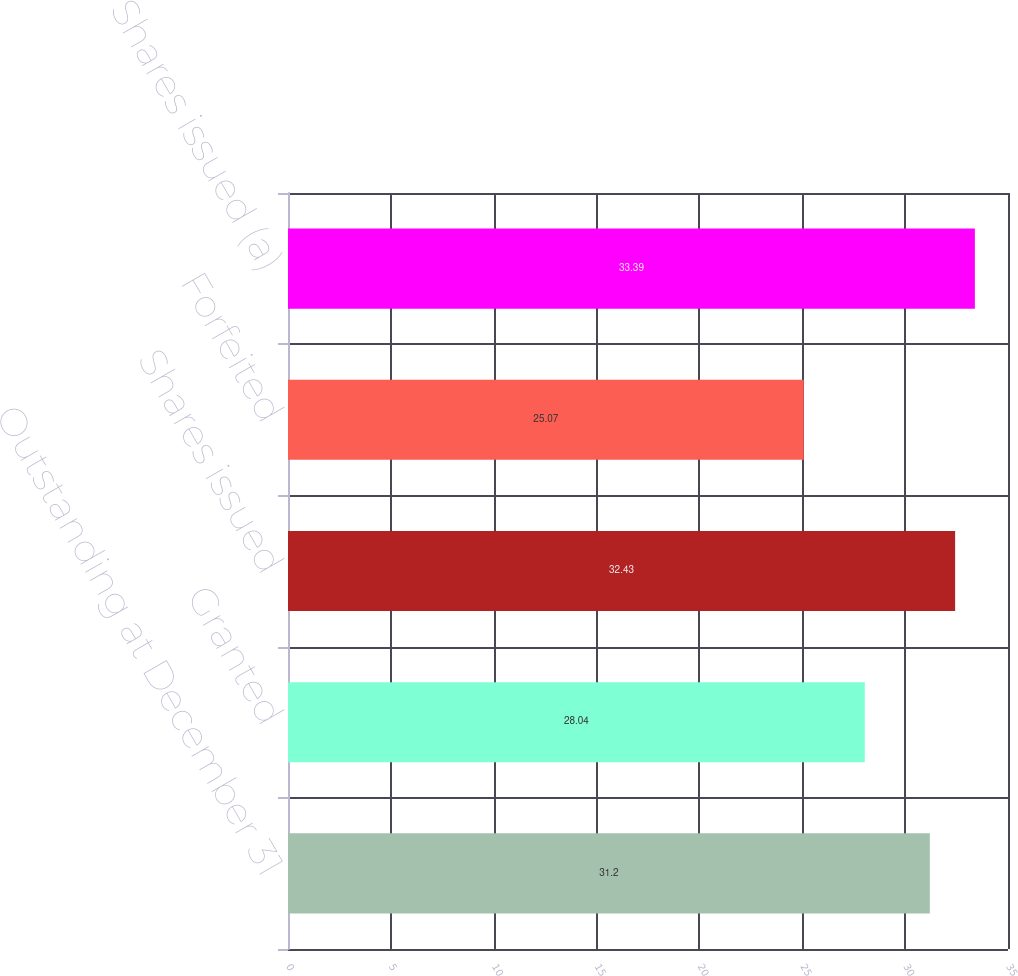<chart> <loc_0><loc_0><loc_500><loc_500><bar_chart><fcel>Outstanding at December 31<fcel>Granted<fcel>Shares issued<fcel>Forfeited<fcel>Shares issued (a)<nl><fcel>31.2<fcel>28.04<fcel>32.43<fcel>25.07<fcel>33.39<nl></chart> 